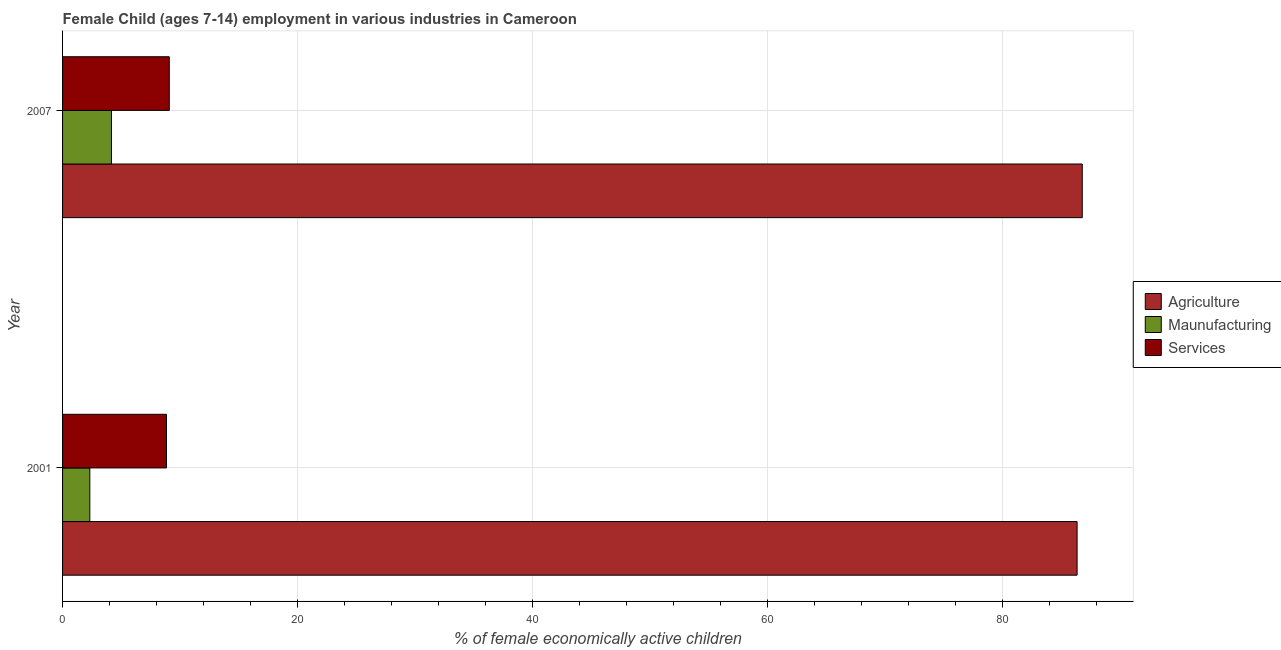Are the number of bars on each tick of the Y-axis equal?
Keep it short and to the point. Yes. What is the percentage of economically active children in services in 2007?
Your answer should be compact. 9.08. Across all years, what is the maximum percentage of economically active children in agriculture?
Offer a very short reply. 86.76. Across all years, what is the minimum percentage of economically active children in services?
Keep it short and to the point. 8.84. In which year was the percentage of economically active children in agriculture minimum?
Keep it short and to the point. 2001. What is the total percentage of economically active children in agriculture in the graph?
Offer a very short reply. 173.08. What is the difference between the percentage of economically active children in agriculture in 2001 and that in 2007?
Give a very brief answer. -0.44. What is the difference between the percentage of economically active children in agriculture in 2007 and the percentage of economically active children in manufacturing in 2001?
Provide a short and direct response. 84.44. What is the average percentage of economically active children in agriculture per year?
Keep it short and to the point. 86.54. In the year 2007, what is the difference between the percentage of economically active children in services and percentage of economically active children in manufacturing?
Provide a succinct answer. 4.92. Is the percentage of economically active children in agriculture in 2001 less than that in 2007?
Make the answer very short. Yes. Is the difference between the percentage of economically active children in manufacturing in 2001 and 2007 greater than the difference between the percentage of economically active children in agriculture in 2001 and 2007?
Keep it short and to the point. No. What does the 3rd bar from the top in 2001 represents?
Your response must be concise. Agriculture. What does the 1st bar from the bottom in 2007 represents?
Keep it short and to the point. Agriculture. Is it the case that in every year, the sum of the percentage of economically active children in agriculture and percentage of economically active children in manufacturing is greater than the percentage of economically active children in services?
Ensure brevity in your answer.  Yes. How many bars are there?
Keep it short and to the point. 6. How many years are there in the graph?
Offer a terse response. 2. Are the values on the major ticks of X-axis written in scientific E-notation?
Your answer should be compact. No. Does the graph contain any zero values?
Make the answer very short. No. Where does the legend appear in the graph?
Your answer should be compact. Center right. How many legend labels are there?
Give a very brief answer. 3. What is the title of the graph?
Provide a succinct answer. Female Child (ages 7-14) employment in various industries in Cameroon. What is the label or title of the X-axis?
Make the answer very short. % of female economically active children. What is the label or title of the Y-axis?
Your response must be concise. Year. What is the % of female economically active children in Agriculture in 2001?
Make the answer very short. 86.32. What is the % of female economically active children in Maunufacturing in 2001?
Provide a succinct answer. 2.32. What is the % of female economically active children of Services in 2001?
Your answer should be compact. 8.84. What is the % of female economically active children of Agriculture in 2007?
Your answer should be very brief. 86.76. What is the % of female economically active children of Maunufacturing in 2007?
Make the answer very short. 4.16. What is the % of female economically active children in Services in 2007?
Make the answer very short. 9.08. Across all years, what is the maximum % of female economically active children in Agriculture?
Your answer should be compact. 86.76. Across all years, what is the maximum % of female economically active children in Maunufacturing?
Provide a succinct answer. 4.16. Across all years, what is the maximum % of female economically active children in Services?
Your answer should be compact. 9.08. Across all years, what is the minimum % of female economically active children in Agriculture?
Ensure brevity in your answer.  86.32. Across all years, what is the minimum % of female economically active children in Maunufacturing?
Your answer should be very brief. 2.32. Across all years, what is the minimum % of female economically active children of Services?
Offer a very short reply. 8.84. What is the total % of female economically active children in Agriculture in the graph?
Keep it short and to the point. 173.08. What is the total % of female economically active children of Maunufacturing in the graph?
Make the answer very short. 6.48. What is the total % of female economically active children of Services in the graph?
Keep it short and to the point. 17.92. What is the difference between the % of female economically active children of Agriculture in 2001 and that in 2007?
Provide a short and direct response. -0.44. What is the difference between the % of female economically active children in Maunufacturing in 2001 and that in 2007?
Provide a short and direct response. -1.84. What is the difference between the % of female economically active children in Services in 2001 and that in 2007?
Ensure brevity in your answer.  -0.24. What is the difference between the % of female economically active children of Agriculture in 2001 and the % of female economically active children of Maunufacturing in 2007?
Offer a terse response. 82.16. What is the difference between the % of female economically active children of Agriculture in 2001 and the % of female economically active children of Services in 2007?
Your answer should be very brief. 77.24. What is the difference between the % of female economically active children of Maunufacturing in 2001 and the % of female economically active children of Services in 2007?
Ensure brevity in your answer.  -6.76. What is the average % of female economically active children of Agriculture per year?
Provide a succinct answer. 86.54. What is the average % of female economically active children of Maunufacturing per year?
Your answer should be compact. 3.24. What is the average % of female economically active children of Services per year?
Provide a succinct answer. 8.96. In the year 2001, what is the difference between the % of female economically active children of Agriculture and % of female economically active children of Maunufacturing?
Give a very brief answer. 84. In the year 2001, what is the difference between the % of female economically active children of Agriculture and % of female economically active children of Services?
Your answer should be very brief. 77.48. In the year 2001, what is the difference between the % of female economically active children in Maunufacturing and % of female economically active children in Services?
Provide a succinct answer. -6.52. In the year 2007, what is the difference between the % of female economically active children of Agriculture and % of female economically active children of Maunufacturing?
Keep it short and to the point. 82.6. In the year 2007, what is the difference between the % of female economically active children of Agriculture and % of female economically active children of Services?
Ensure brevity in your answer.  77.68. In the year 2007, what is the difference between the % of female economically active children of Maunufacturing and % of female economically active children of Services?
Ensure brevity in your answer.  -4.92. What is the ratio of the % of female economically active children in Agriculture in 2001 to that in 2007?
Offer a terse response. 0.99. What is the ratio of the % of female economically active children in Maunufacturing in 2001 to that in 2007?
Keep it short and to the point. 0.56. What is the ratio of the % of female economically active children in Services in 2001 to that in 2007?
Provide a short and direct response. 0.97. What is the difference between the highest and the second highest % of female economically active children in Agriculture?
Your answer should be compact. 0.44. What is the difference between the highest and the second highest % of female economically active children in Maunufacturing?
Keep it short and to the point. 1.84. What is the difference between the highest and the second highest % of female economically active children in Services?
Your answer should be compact. 0.24. What is the difference between the highest and the lowest % of female economically active children of Agriculture?
Keep it short and to the point. 0.44. What is the difference between the highest and the lowest % of female economically active children of Maunufacturing?
Your answer should be very brief. 1.84. What is the difference between the highest and the lowest % of female economically active children in Services?
Provide a succinct answer. 0.24. 